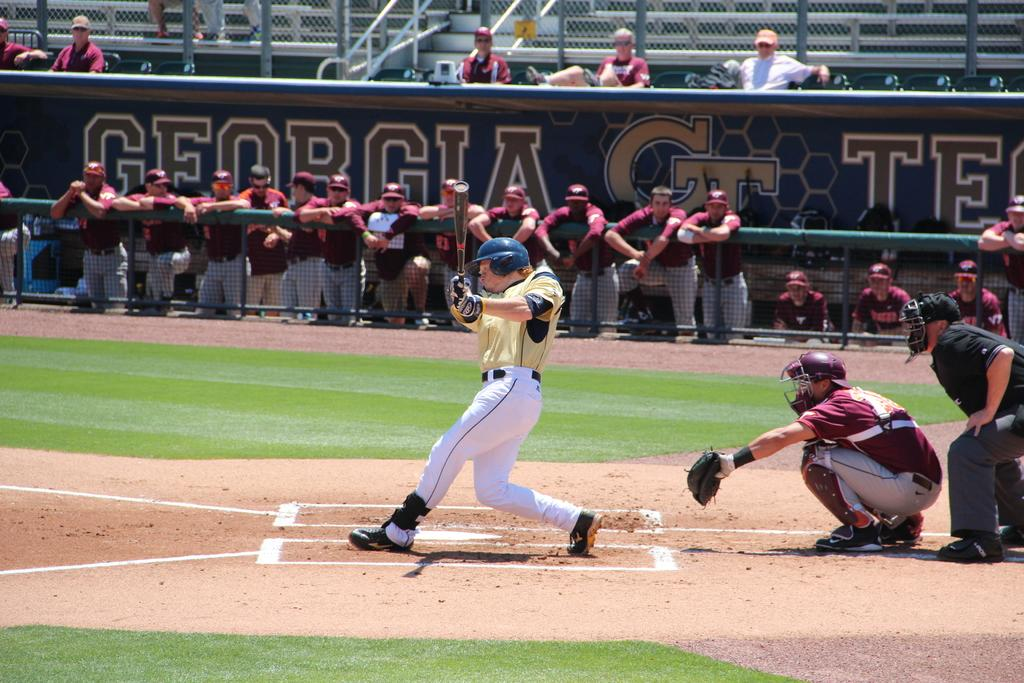<image>
Describe the image concisely. Georgia is the state for one of the baseball teams playing. 